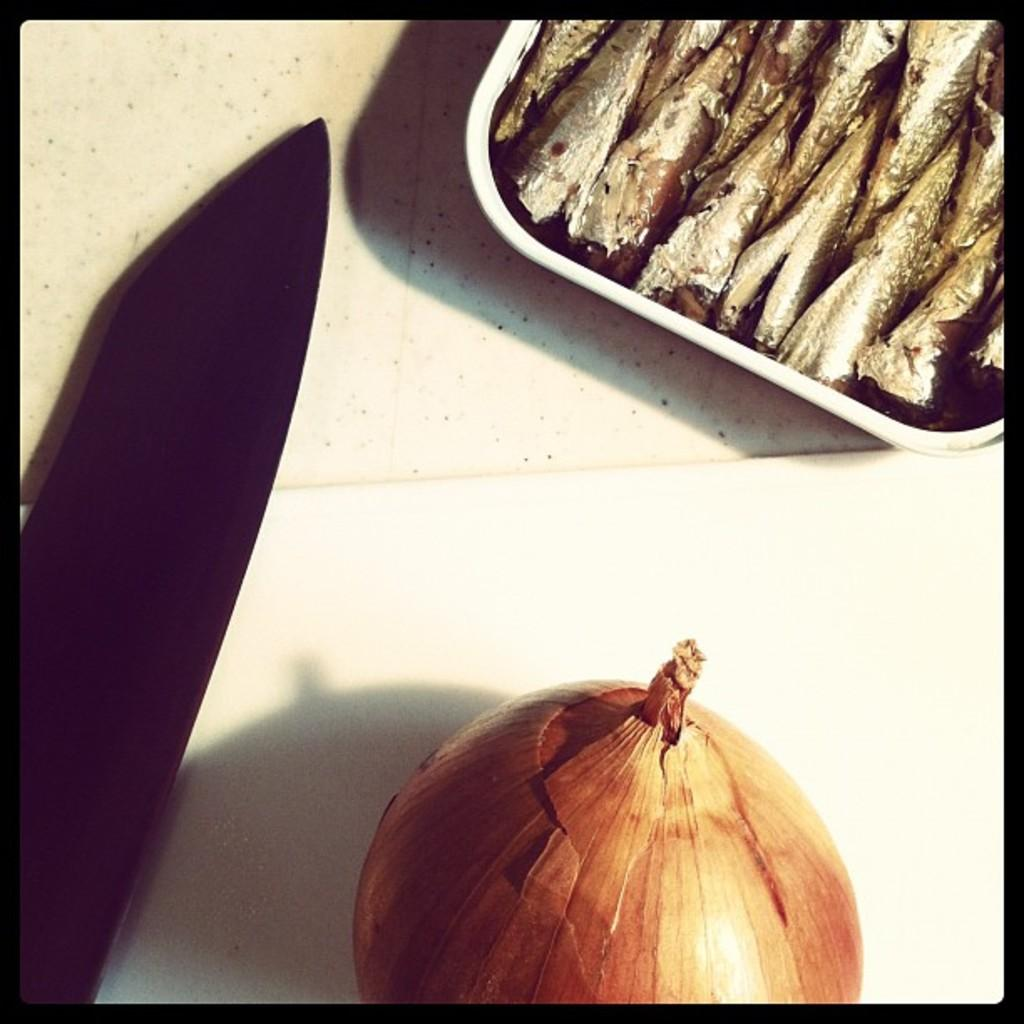What is in the tray that is visible in the image? There are food items in the tray. Can you identify any specific food item in the image? Yes, an onion is visible in the image. What tool is present in the image? A knife is present in the image. What is the color of the surface in the image? The surface in the image is white. What type of cloth is draped over the food items in the image? There is no cloth draped over the food items in the image; the surface is white and the food items are visible. 